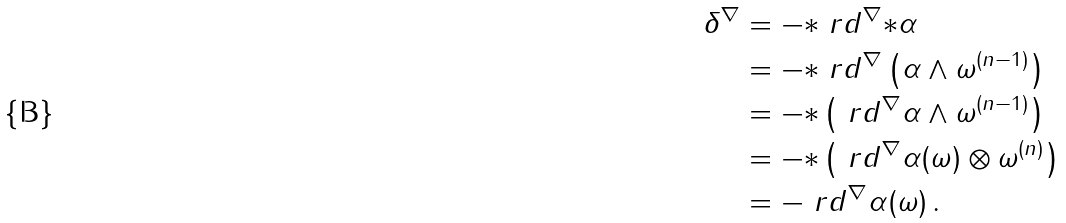<formula> <loc_0><loc_0><loc_500><loc_500>\delta ^ { \nabla } & = - { \ast \ r d ^ { \nabla } } { \ast \alpha } \\ & = - { \ast \ r d ^ { \nabla } } \left ( \alpha \wedge \omega ^ { ( n - 1 ) } \right ) \\ & = { - \ast } \left ( \ r d ^ { \nabla } \alpha \wedge \omega ^ { ( n - 1 ) } \right ) \\ & = { - \ast } \left ( \ r d ^ { \nabla } \alpha ( \omega ) \otimes \omega ^ { ( n ) } \right ) \\ & = - \ r d ^ { \nabla } \alpha ( \omega ) \, .</formula> 